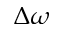<formula> <loc_0><loc_0><loc_500><loc_500>\Delta \omega</formula> 